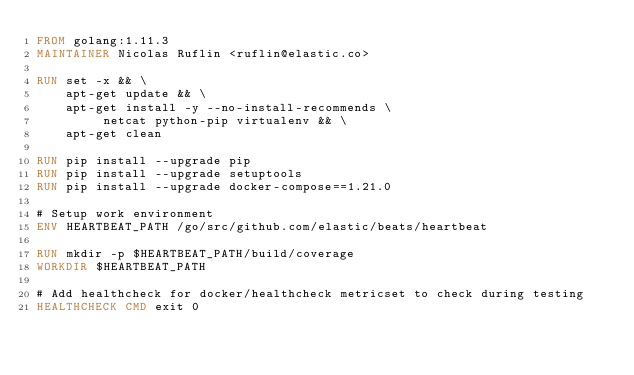<code> <loc_0><loc_0><loc_500><loc_500><_Dockerfile_>FROM golang:1.11.3
MAINTAINER Nicolas Ruflin <ruflin@elastic.co>

RUN set -x && \
    apt-get update && \
    apt-get install -y --no-install-recommends \
         netcat python-pip virtualenv && \
    apt-get clean

RUN pip install --upgrade pip
RUN pip install --upgrade setuptools
RUN pip install --upgrade docker-compose==1.21.0

# Setup work environment
ENV HEARTBEAT_PATH /go/src/github.com/elastic/beats/heartbeat

RUN mkdir -p $HEARTBEAT_PATH/build/coverage
WORKDIR $HEARTBEAT_PATH

# Add healthcheck for docker/healthcheck metricset to check during testing
HEALTHCHECK CMD exit 0
</code> 